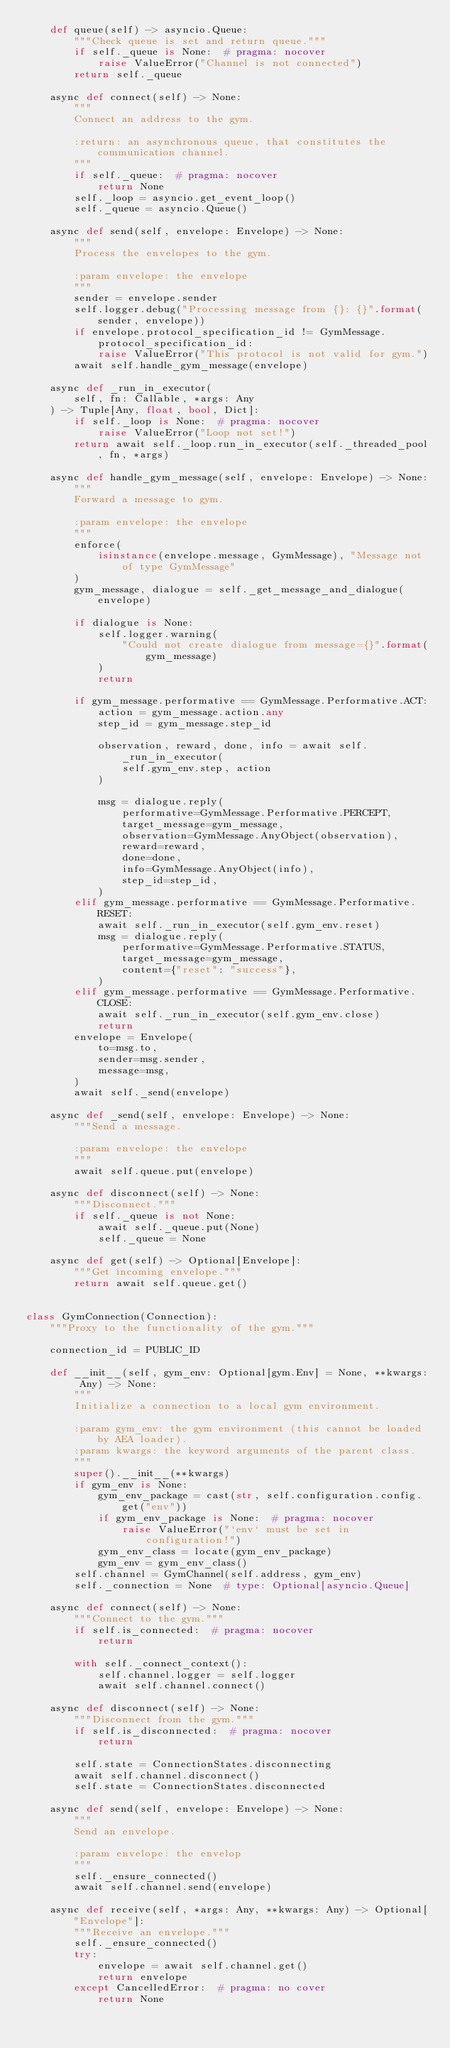<code> <loc_0><loc_0><loc_500><loc_500><_Python_>    def queue(self) -> asyncio.Queue:
        """Check queue is set and return queue."""
        if self._queue is None:  # pragma: nocover
            raise ValueError("Channel is not connected")
        return self._queue

    async def connect(self) -> None:
        """
        Connect an address to the gym.

        :return: an asynchronous queue, that constitutes the communication channel.
        """
        if self._queue:  # pragma: nocover
            return None
        self._loop = asyncio.get_event_loop()
        self._queue = asyncio.Queue()

    async def send(self, envelope: Envelope) -> None:
        """
        Process the envelopes to the gym.

        :param envelope: the envelope
        """
        sender = envelope.sender
        self.logger.debug("Processing message from {}: {}".format(sender, envelope))
        if envelope.protocol_specification_id != GymMessage.protocol_specification_id:
            raise ValueError("This protocol is not valid for gym.")
        await self.handle_gym_message(envelope)

    async def _run_in_executor(
        self, fn: Callable, *args: Any
    ) -> Tuple[Any, float, bool, Dict]:
        if self._loop is None:  # pragma: nocover
            raise ValueError("Loop not set!")
        return await self._loop.run_in_executor(self._threaded_pool, fn, *args)

    async def handle_gym_message(self, envelope: Envelope) -> None:
        """
        Forward a message to gym.

        :param envelope: the envelope
        """
        enforce(
            isinstance(envelope.message, GymMessage), "Message not of type GymMessage"
        )
        gym_message, dialogue = self._get_message_and_dialogue(envelope)

        if dialogue is None:
            self.logger.warning(
                "Could not create dialogue from message={}".format(gym_message)
            )
            return

        if gym_message.performative == GymMessage.Performative.ACT:
            action = gym_message.action.any
            step_id = gym_message.step_id

            observation, reward, done, info = await self._run_in_executor(
                self.gym_env.step, action
            )

            msg = dialogue.reply(
                performative=GymMessage.Performative.PERCEPT,
                target_message=gym_message,
                observation=GymMessage.AnyObject(observation),
                reward=reward,
                done=done,
                info=GymMessage.AnyObject(info),
                step_id=step_id,
            )
        elif gym_message.performative == GymMessage.Performative.RESET:
            await self._run_in_executor(self.gym_env.reset)
            msg = dialogue.reply(
                performative=GymMessage.Performative.STATUS,
                target_message=gym_message,
                content={"reset": "success"},
            )
        elif gym_message.performative == GymMessage.Performative.CLOSE:
            await self._run_in_executor(self.gym_env.close)
            return
        envelope = Envelope(
            to=msg.to,
            sender=msg.sender,
            message=msg,
        )
        await self._send(envelope)

    async def _send(self, envelope: Envelope) -> None:
        """Send a message.

        :param envelope: the envelope
        """
        await self.queue.put(envelope)

    async def disconnect(self) -> None:
        """Disconnect."""
        if self._queue is not None:
            await self._queue.put(None)
            self._queue = None

    async def get(self) -> Optional[Envelope]:
        """Get incoming envelope."""
        return await self.queue.get()


class GymConnection(Connection):
    """Proxy to the functionality of the gym."""

    connection_id = PUBLIC_ID

    def __init__(self, gym_env: Optional[gym.Env] = None, **kwargs: Any) -> None:
        """
        Initialize a connection to a local gym environment.

        :param gym_env: the gym environment (this cannot be loaded by AEA loader).
        :param kwargs: the keyword arguments of the parent class.
        """
        super().__init__(**kwargs)
        if gym_env is None:
            gym_env_package = cast(str, self.configuration.config.get("env"))
            if gym_env_package is None:  # pragma: nocover
                raise ValueError("`env` must be set in configuration!")
            gym_env_class = locate(gym_env_package)
            gym_env = gym_env_class()
        self.channel = GymChannel(self.address, gym_env)
        self._connection = None  # type: Optional[asyncio.Queue]

    async def connect(self) -> None:
        """Connect to the gym."""
        if self.is_connected:  # pragma: nocover
            return

        with self._connect_context():
            self.channel.logger = self.logger
            await self.channel.connect()

    async def disconnect(self) -> None:
        """Disconnect from the gym."""
        if self.is_disconnected:  # pragma: nocover
            return

        self.state = ConnectionStates.disconnecting
        await self.channel.disconnect()
        self.state = ConnectionStates.disconnected

    async def send(self, envelope: Envelope) -> None:
        """
        Send an envelope.

        :param envelope: the envelop
        """
        self._ensure_connected()
        await self.channel.send(envelope)

    async def receive(self, *args: Any, **kwargs: Any) -> Optional["Envelope"]:
        """Receive an envelope."""
        self._ensure_connected()
        try:
            envelope = await self.channel.get()
            return envelope
        except CancelledError:  # pragma: no cover
            return None
</code> 